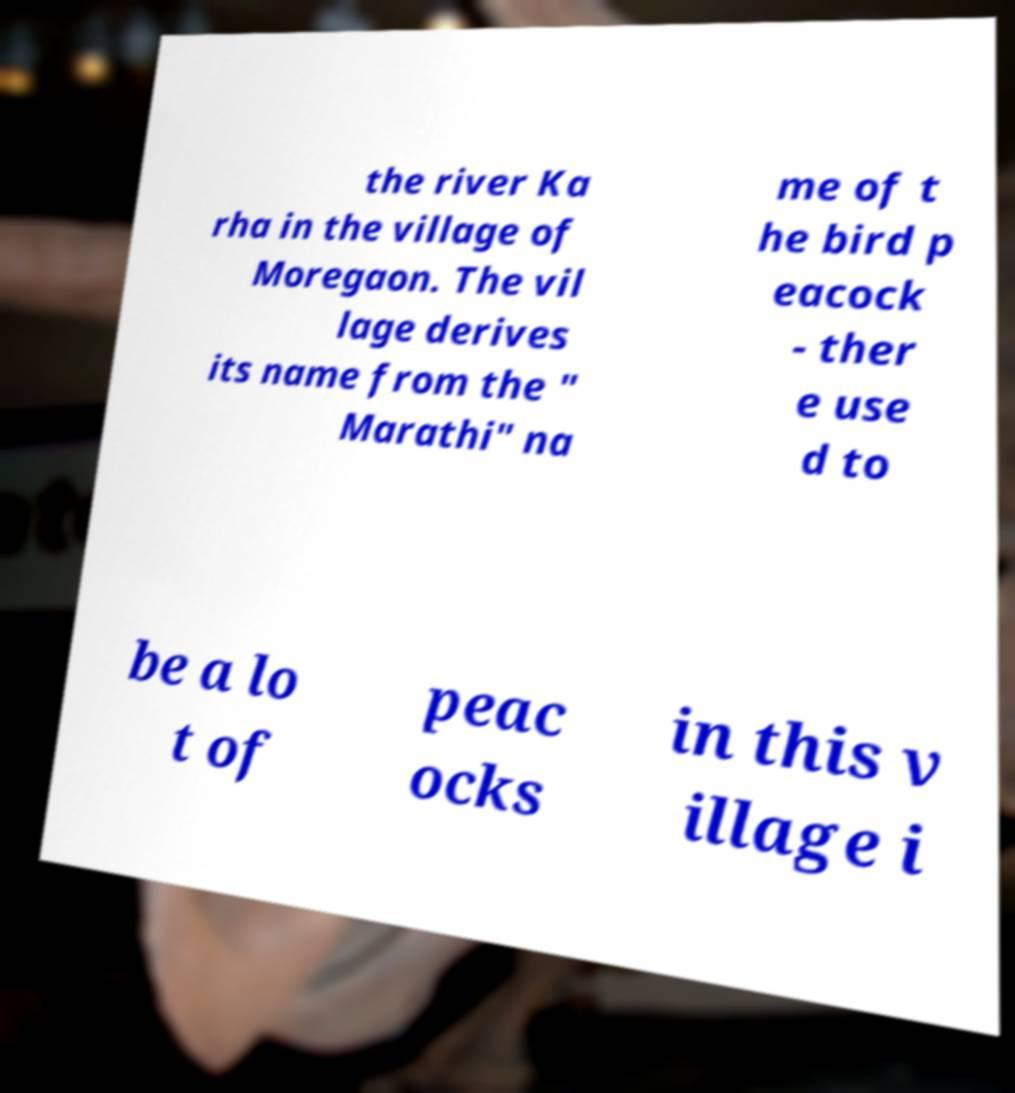Could you assist in decoding the text presented in this image and type it out clearly? the river Ka rha in the village of Moregaon. The vil lage derives its name from the " Marathi" na me of t he bird p eacock - ther e use d to be a lo t of peac ocks in this v illage i 